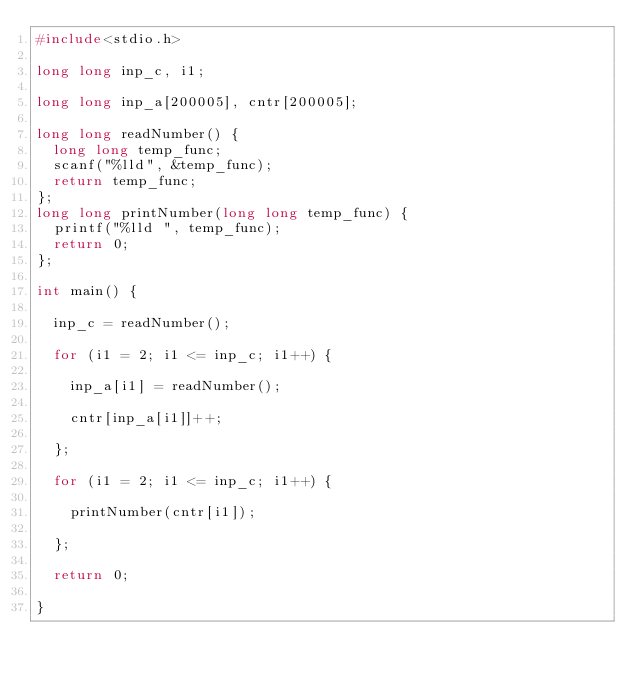Convert code to text. <code><loc_0><loc_0><loc_500><loc_500><_C++_>#include<stdio.h>

long long inp_c, i1;

long long inp_a[200005], cntr[200005];

long long readNumber() {
	long long temp_func;
	scanf("%lld", &temp_func);
	return temp_func;
};
long long printNumber(long long temp_func) {
	printf("%lld ", temp_func);
	return 0;
};

int main() {
	
	inp_c = readNumber();
	
	for (i1 = 2; i1 <= inp_c; i1++) {
		
		inp_a[i1] = readNumber();
		
		cntr[inp_a[i1]]++;
		
	};
	
	for (i1 = 2; i1 <= inp_c; i1++) {
		
		printNumber(cntr[i1]);
		
	};
	
	return 0;
	
}</code> 